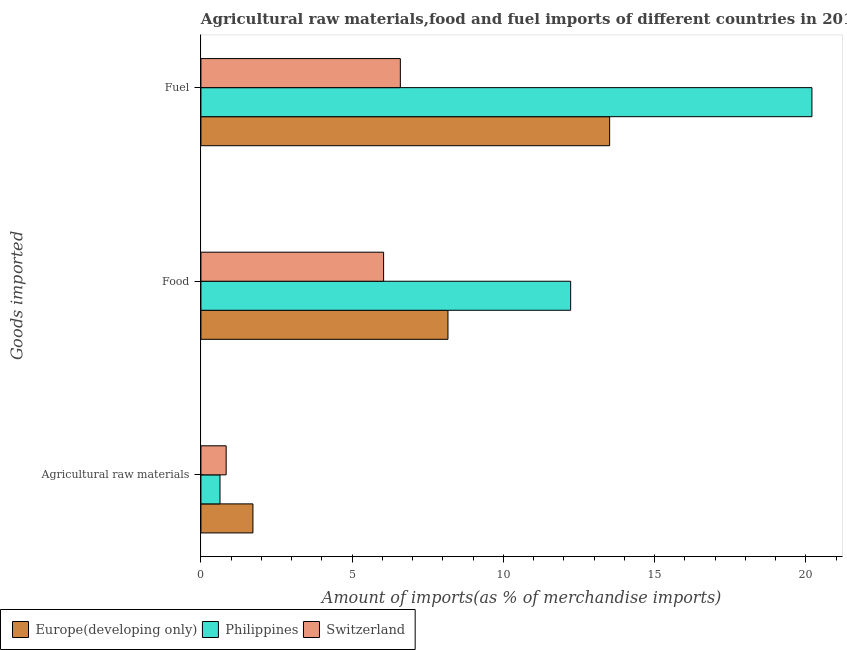How many groups of bars are there?
Your answer should be very brief. 3. What is the label of the 1st group of bars from the top?
Your response must be concise. Fuel. What is the percentage of food imports in Switzerland?
Your answer should be compact. 6.04. Across all countries, what is the maximum percentage of fuel imports?
Your answer should be very brief. 20.2. Across all countries, what is the minimum percentage of food imports?
Provide a succinct answer. 6.04. In which country was the percentage of fuel imports maximum?
Your answer should be compact. Philippines. In which country was the percentage of food imports minimum?
Offer a very short reply. Switzerland. What is the total percentage of food imports in the graph?
Offer a terse response. 26.43. What is the difference between the percentage of food imports in Switzerland and that in Europe(developing only)?
Your answer should be compact. -2.13. What is the difference between the percentage of raw materials imports in Europe(developing only) and the percentage of food imports in Switzerland?
Make the answer very short. -4.32. What is the average percentage of raw materials imports per country?
Your answer should be compact. 1.06. What is the difference between the percentage of food imports and percentage of raw materials imports in Switzerland?
Make the answer very short. 5.21. What is the ratio of the percentage of raw materials imports in Philippines to that in Europe(developing only)?
Give a very brief answer. 0.37. What is the difference between the highest and the second highest percentage of fuel imports?
Provide a short and direct response. 6.69. What is the difference between the highest and the lowest percentage of food imports?
Keep it short and to the point. 6.18. Is the sum of the percentage of fuel imports in Philippines and Europe(developing only) greater than the maximum percentage of food imports across all countries?
Your answer should be compact. Yes. What does the 1st bar from the top in Agricultural raw materials represents?
Keep it short and to the point. Switzerland. What does the 3rd bar from the bottom in Agricultural raw materials represents?
Make the answer very short. Switzerland. Is it the case that in every country, the sum of the percentage of raw materials imports and percentage of food imports is greater than the percentage of fuel imports?
Give a very brief answer. No. How many bars are there?
Ensure brevity in your answer.  9. Are all the bars in the graph horizontal?
Provide a short and direct response. Yes. How many legend labels are there?
Your answer should be compact. 3. How are the legend labels stacked?
Make the answer very short. Horizontal. What is the title of the graph?
Make the answer very short. Agricultural raw materials,food and fuel imports of different countries in 2014. What is the label or title of the X-axis?
Offer a terse response. Amount of imports(as % of merchandise imports). What is the label or title of the Y-axis?
Offer a very short reply. Goods imported. What is the Amount of imports(as % of merchandise imports) in Europe(developing only) in Agricultural raw materials?
Give a very brief answer. 1.72. What is the Amount of imports(as % of merchandise imports) of Philippines in Agricultural raw materials?
Provide a short and direct response. 0.63. What is the Amount of imports(as % of merchandise imports) in Switzerland in Agricultural raw materials?
Your answer should be compact. 0.83. What is the Amount of imports(as % of merchandise imports) in Europe(developing only) in Food?
Keep it short and to the point. 8.17. What is the Amount of imports(as % of merchandise imports) of Philippines in Food?
Offer a terse response. 12.22. What is the Amount of imports(as % of merchandise imports) of Switzerland in Food?
Provide a succinct answer. 6.04. What is the Amount of imports(as % of merchandise imports) of Europe(developing only) in Fuel?
Give a very brief answer. 13.51. What is the Amount of imports(as % of merchandise imports) in Philippines in Fuel?
Provide a succinct answer. 20.2. What is the Amount of imports(as % of merchandise imports) of Switzerland in Fuel?
Your answer should be compact. 6.59. Across all Goods imported, what is the maximum Amount of imports(as % of merchandise imports) in Europe(developing only)?
Keep it short and to the point. 13.51. Across all Goods imported, what is the maximum Amount of imports(as % of merchandise imports) in Philippines?
Offer a very short reply. 20.2. Across all Goods imported, what is the maximum Amount of imports(as % of merchandise imports) of Switzerland?
Your answer should be very brief. 6.59. Across all Goods imported, what is the minimum Amount of imports(as % of merchandise imports) in Europe(developing only)?
Your answer should be compact. 1.72. Across all Goods imported, what is the minimum Amount of imports(as % of merchandise imports) of Philippines?
Your answer should be very brief. 0.63. Across all Goods imported, what is the minimum Amount of imports(as % of merchandise imports) in Switzerland?
Your answer should be compact. 0.83. What is the total Amount of imports(as % of merchandise imports) of Europe(developing only) in the graph?
Provide a short and direct response. 23.4. What is the total Amount of imports(as % of merchandise imports) in Philippines in the graph?
Your answer should be very brief. 33.06. What is the total Amount of imports(as % of merchandise imports) in Switzerland in the graph?
Your response must be concise. 13.47. What is the difference between the Amount of imports(as % of merchandise imports) of Europe(developing only) in Agricultural raw materials and that in Food?
Provide a succinct answer. -6.45. What is the difference between the Amount of imports(as % of merchandise imports) of Philippines in Agricultural raw materials and that in Food?
Give a very brief answer. -11.59. What is the difference between the Amount of imports(as % of merchandise imports) in Switzerland in Agricultural raw materials and that in Food?
Make the answer very short. -5.21. What is the difference between the Amount of imports(as % of merchandise imports) in Europe(developing only) in Agricultural raw materials and that in Fuel?
Ensure brevity in your answer.  -11.79. What is the difference between the Amount of imports(as % of merchandise imports) in Philippines in Agricultural raw materials and that in Fuel?
Offer a very short reply. -19.57. What is the difference between the Amount of imports(as % of merchandise imports) of Switzerland in Agricultural raw materials and that in Fuel?
Your answer should be very brief. -5.76. What is the difference between the Amount of imports(as % of merchandise imports) in Europe(developing only) in Food and that in Fuel?
Your answer should be very brief. -5.35. What is the difference between the Amount of imports(as % of merchandise imports) of Philippines in Food and that in Fuel?
Ensure brevity in your answer.  -7.98. What is the difference between the Amount of imports(as % of merchandise imports) of Switzerland in Food and that in Fuel?
Offer a terse response. -0.55. What is the difference between the Amount of imports(as % of merchandise imports) in Europe(developing only) in Agricultural raw materials and the Amount of imports(as % of merchandise imports) in Philippines in Food?
Offer a very short reply. -10.5. What is the difference between the Amount of imports(as % of merchandise imports) of Europe(developing only) in Agricultural raw materials and the Amount of imports(as % of merchandise imports) of Switzerland in Food?
Provide a short and direct response. -4.32. What is the difference between the Amount of imports(as % of merchandise imports) in Philippines in Agricultural raw materials and the Amount of imports(as % of merchandise imports) in Switzerland in Food?
Give a very brief answer. -5.41. What is the difference between the Amount of imports(as % of merchandise imports) in Europe(developing only) in Agricultural raw materials and the Amount of imports(as % of merchandise imports) in Philippines in Fuel?
Offer a terse response. -18.48. What is the difference between the Amount of imports(as % of merchandise imports) in Europe(developing only) in Agricultural raw materials and the Amount of imports(as % of merchandise imports) in Switzerland in Fuel?
Make the answer very short. -4.87. What is the difference between the Amount of imports(as % of merchandise imports) of Philippines in Agricultural raw materials and the Amount of imports(as % of merchandise imports) of Switzerland in Fuel?
Ensure brevity in your answer.  -5.96. What is the difference between the Amount of imports(as % of merchandise imports) of Europe(developing only) in Food and the Amount of imports(as % of merchandise imports) of Philippines in Fuel?
Ensure brevity in your answer.  -12.03. What is the difference between the Amount of imports(as % of merchandise imports) in Europe(developing only) in Food and the Amount of imports(as % of merchandise imports) in Switzerland in Fuel?
Offer a very short reply. 1.57. What is the difference between the Amount of imports(as % of merchandise imports) of Philippines in Food and the Amount of imports(as % of merchandise imports) of Switzerland in Fuel?
Make the answer very short. 5.63. What is the average Amount of imports(as % of merchandise imports) in Europe(developing only) per Goods imported?
Offer a terse response. 7.8. What is the average Amount of imports(as % of merchandise imports) in Philippines per Goods imported?
Keep it short and to the point. 11.02. What is the average Amount of imports(as % of merchandise imports) of Switzerland per Goods imported?
Your answer should be very brief. 4.49. What is the difference between the Amount of imports(as % of merchandise imports) in Europe(developing only) and Amount of imports(as % of merchandise imports) in Philippines in Agricultural raw materials?
Make the answer very short. 1.09. What is the difference between the Amount of imports(as % of merchandise imports) in Europe(developing only) and Amount of imports(as % of merchandise imports) in Switzerland in Agricultural raw materials?
Offer a very short reply. 0.88. What is the difference between the Amount of imports(as % of merchandise imports) in Philippines and Amount of imports(as % of merchandise imports) in Switzerland in Agricultural raw materials?
Provide a short and direct response. -0.2. What is the difference between the Amount of imports(as % of merchandise imports) of Europe(developing only) and Amount of imports(as % of merchandise imports) of Philippines in Food?
Provide a short and direct response. -4.06. What is the difference between the Amount of imports(as % of merchandise imports) of Europe(developing only) and Amount of imports(as % of merchandise imports) of Switzerland in Food?
Ensure brevity in your answer.  2.13. What is the difference between the Amount of imports(as % of merchandise imports) of Philippines and Amount of imports(as % of merchandise imports) of Switzerland in Food?
Offer a terse response. 6.18. What is the difference between the Amount of imports(as % of merchandise imports) in Europe(developing only) and Amount of imports(as % of merchandise imports) in Philippines in Fuel?
Make the answer very short. -6.69. What is the difference between the Amount of imports(as % of merchandise imports) of Europe(developing only) and Amount of imports(as % of merchandise imports) of Switzerland in Fuel?
Offer a very short reply. 6.92. What is the difference between the Amount of imports(as % of merchandise imports) in Philippines and Amount of imports(as % of merchandise imports) in Switzerland in Fuel?
Offer a terse response. 13.61. What is the ratio of the Amount of imports(as % of merchandise imports) in Europe(developing only) in Agricultural raw materials to that in Food?
Give a very brief answer. 0.21. What is the ratio of the Amount of imports(as % of merchandise imports) in Philippines in Agricultural raw materials to that in Food?
Your answer should be compact. 0.05. What is the ratio of the Amount of imports(as % of merchandise imports) of Switzerland in Agricultural raw materials to that in Food?
Keep it short and to the point. 0.14. What is the ratio of the Amount of imports(as % of merchandise imports) of Europe(developing only) in Agricultural raw materials to that in Fuel?
Give a very brief answer. 0.13. What is the ratio of the Amount of imports(as % of merchandise imports) of Philippines in Agricultural raw materials to that in Fuel?
Your answer should be very brief. 0.03. What is the ratio of the Amount of imports(as % of merchandise imports) in Switzerland in Agricultural raw materials to that in Fuel?
Give a very brief answer. 0.13. What is the ratio of the Amount of imports(as % of merchandise imports) of Europe(developing only) in Food to that in Fuel?
Make the answer very short. 0.6. What is the ratio of the Amount of imports(as % of merchandise imports) of Philippines in Food to that in Fuel?
Give a very brief answer. 0.61. What is the ratio of the Amount of imports(as % of merchandise imports) of Switzerland in Food to that in Fuel?
Your answer should be compact. 0.92. What is the difference between the highest and the second highest Amount of imports(as % of merchandise imports) of Europe(developing only)?
Ensure brevity in your answer.  5.35. What is the difference between the highest and the second highest Amount of imports(as % of merchandise imports) of Philippines?
Make the answer very short. 7.98. What is the difference between the highest and the second highest Amount of imports(as % of merchandise imports) in Switzerland?
Give a very brief answer. 0.55. What is the difference between the highest and the lowest Amount of imports(as % of merchandise imports) of Europe(developing only)?
Keep it short and to the point. 11.79. What is the difference between the highest and the lowest Amount of imports(as % of merchandise imports) in Philippines?
Offer a terse response. 19.57. What is the difference between the highest and the lowest Amount of imports(as % of merchandise imports) of Switzerland?
Provide a succinct answer. 5.76. 